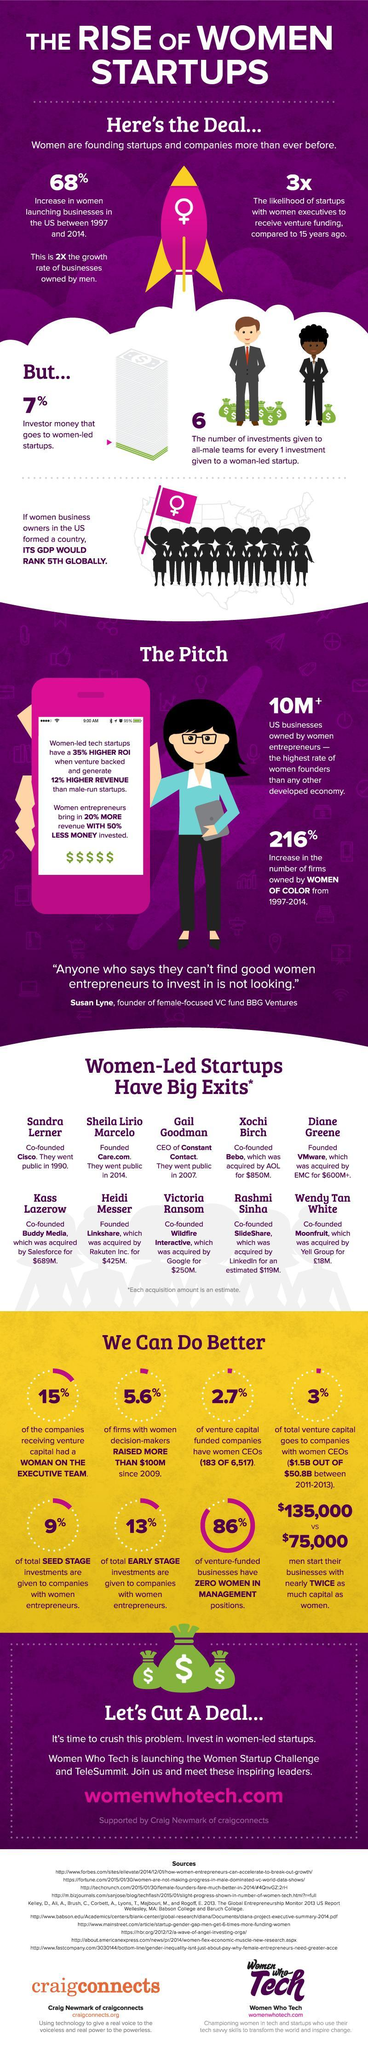By what percent did women-led businesses increase in the US during the period 1997-2014?
Answer the question with a short phrase. 68% Who was the co-founder of Cisco? Sandra Lerner SlideShare was acquired by which company? LinkedIn What percent of total early stage investments are given to companies with women entrepreneurs? 13% By how many times has the prospect of receiving venture funding increased for women-led startups? 3x Who was the CEO of Constant Contact? Gail Goodman Who was the co-founder of Wildfire Interactive? Victoria Ransom What percent of venture capital funded companies have women CEOs? 2.7% Which company was founded by Diane Greene? VMware Which company was acquired by Rakuten Inc. for $425 million? Linkshare 